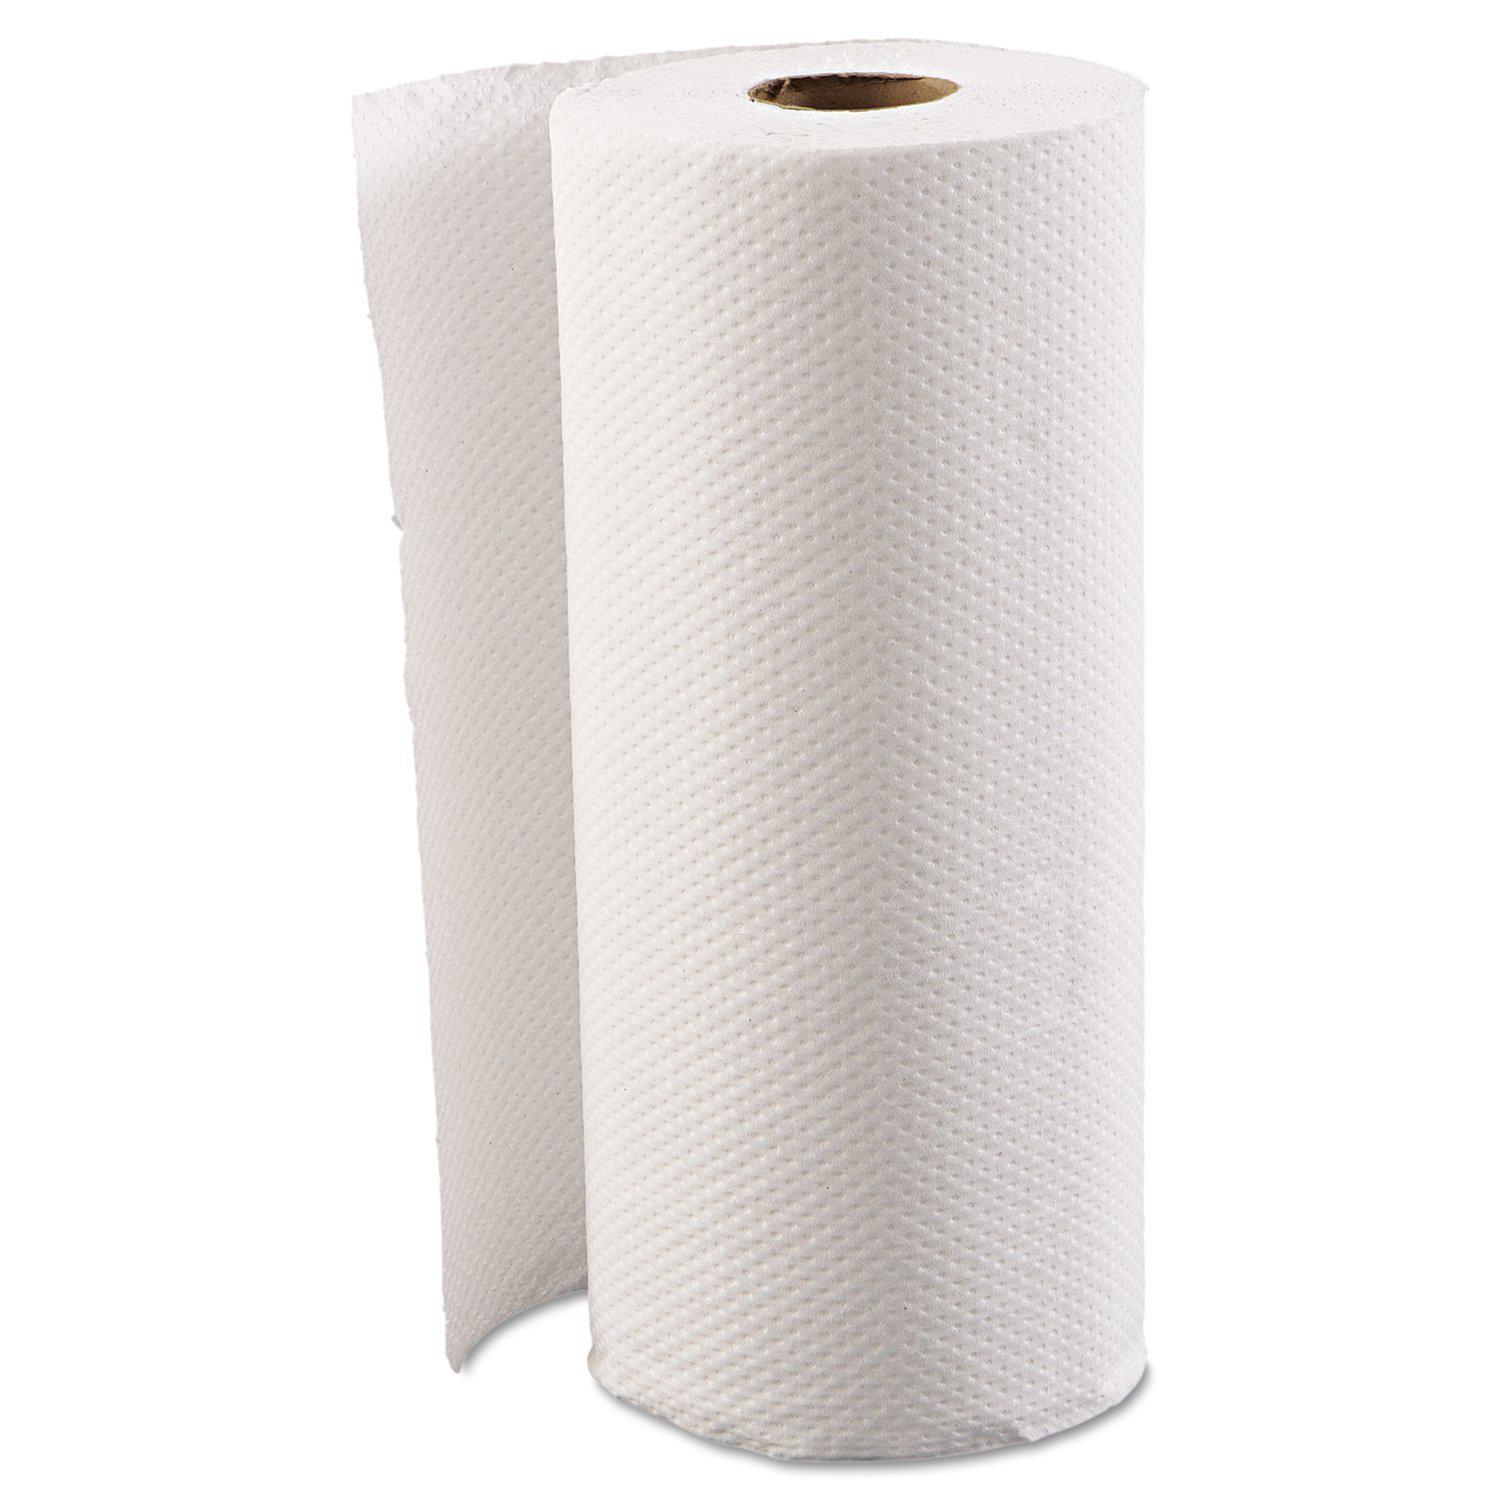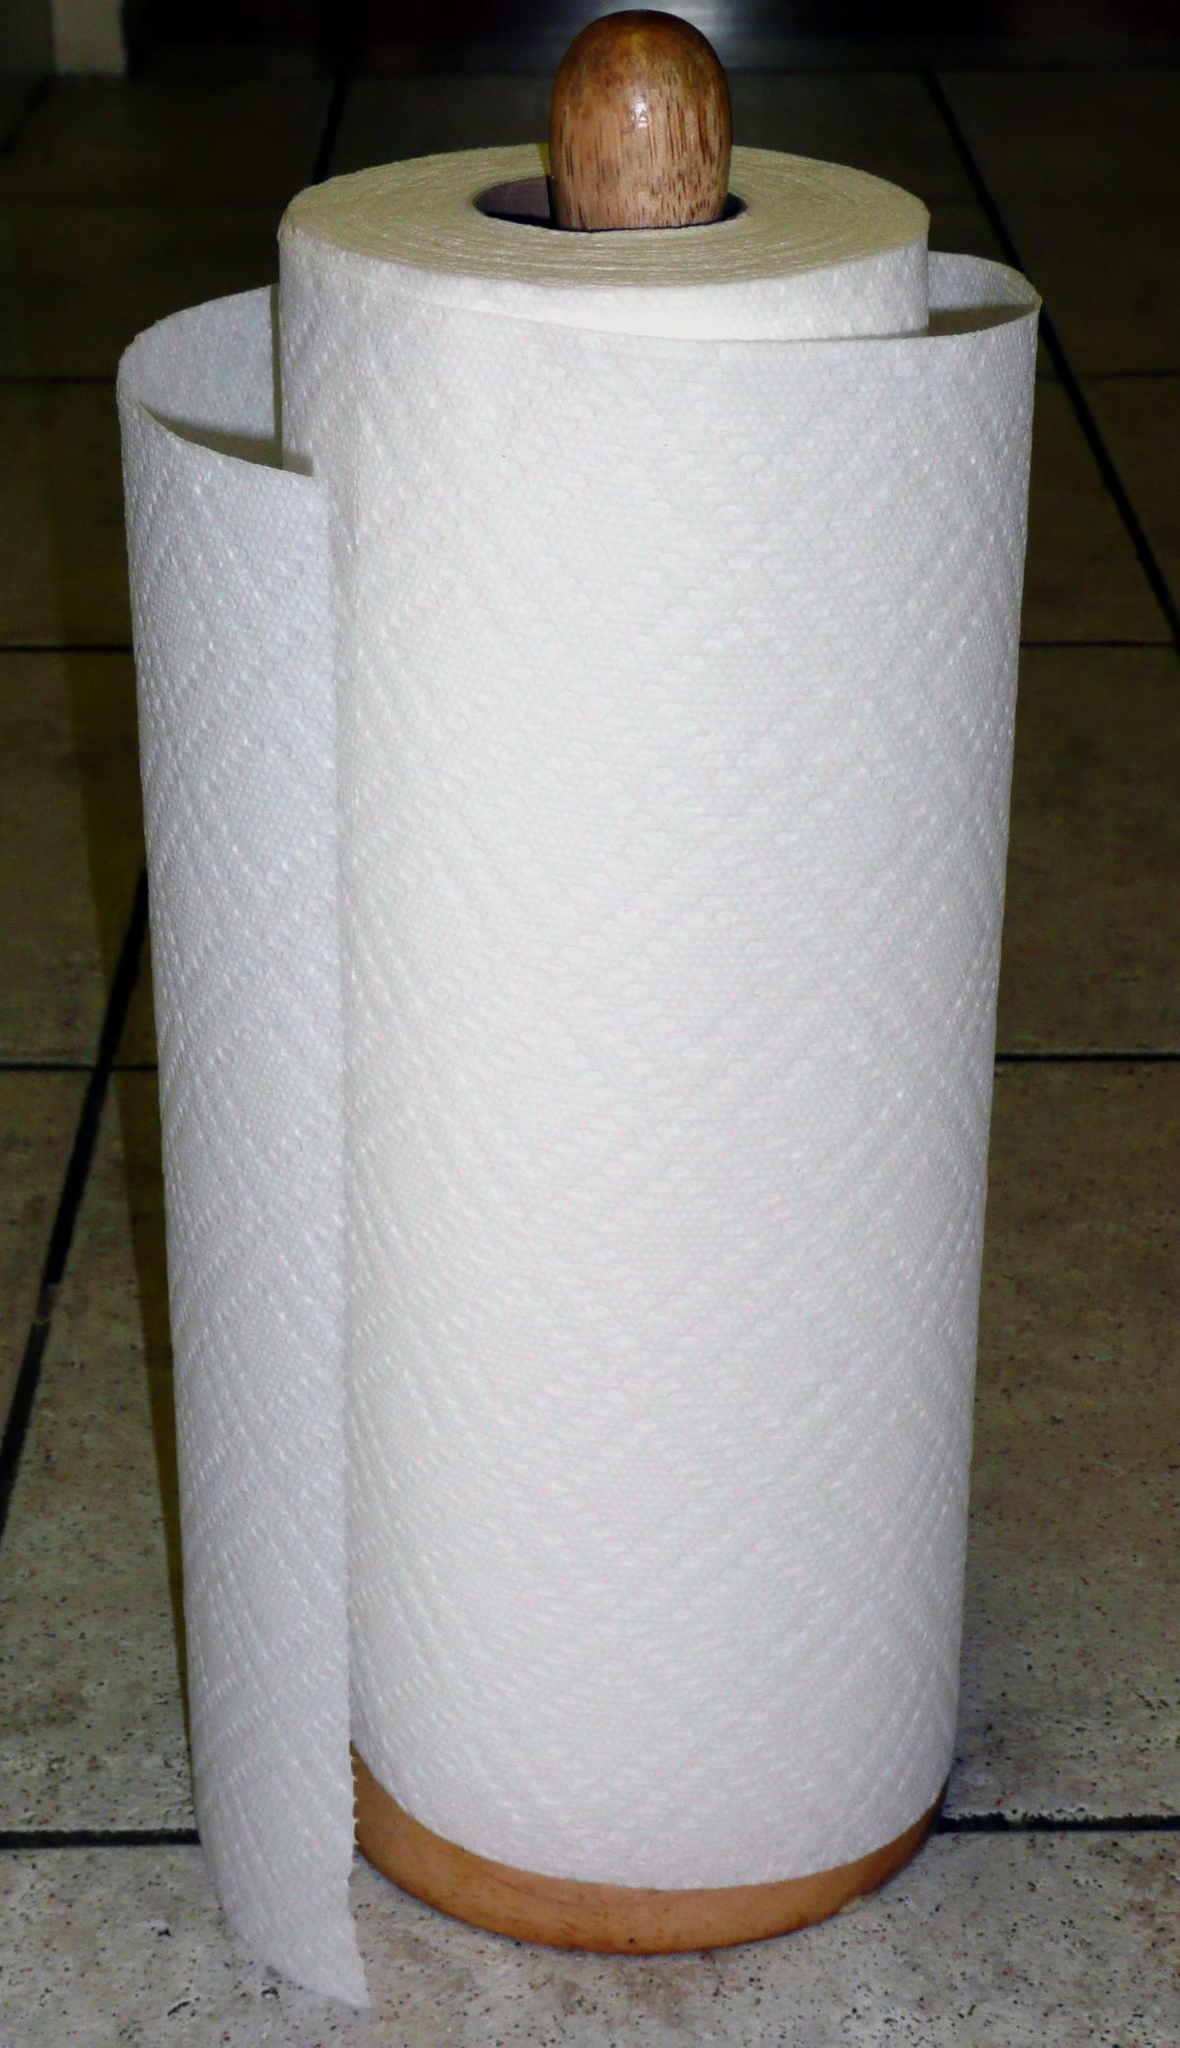The first image is the image on the left, the second image is the image on the right. Considering the images on both sides, is "There is exactly one roll of paper towels in the image on the left." valid? Answer yes or no. Yes. 